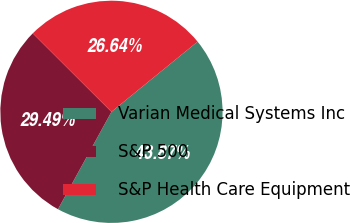<chart> <loc_0><loc_0><loc_500><loc_500><pie_chart><fcel>Varian Medical Systems Inc<fcel>S&P 500<fcel>S&P Health Care Equipment<nl><fcel>43.87%<fcel>29.49%<fcel>26.64%<nl></chart> 